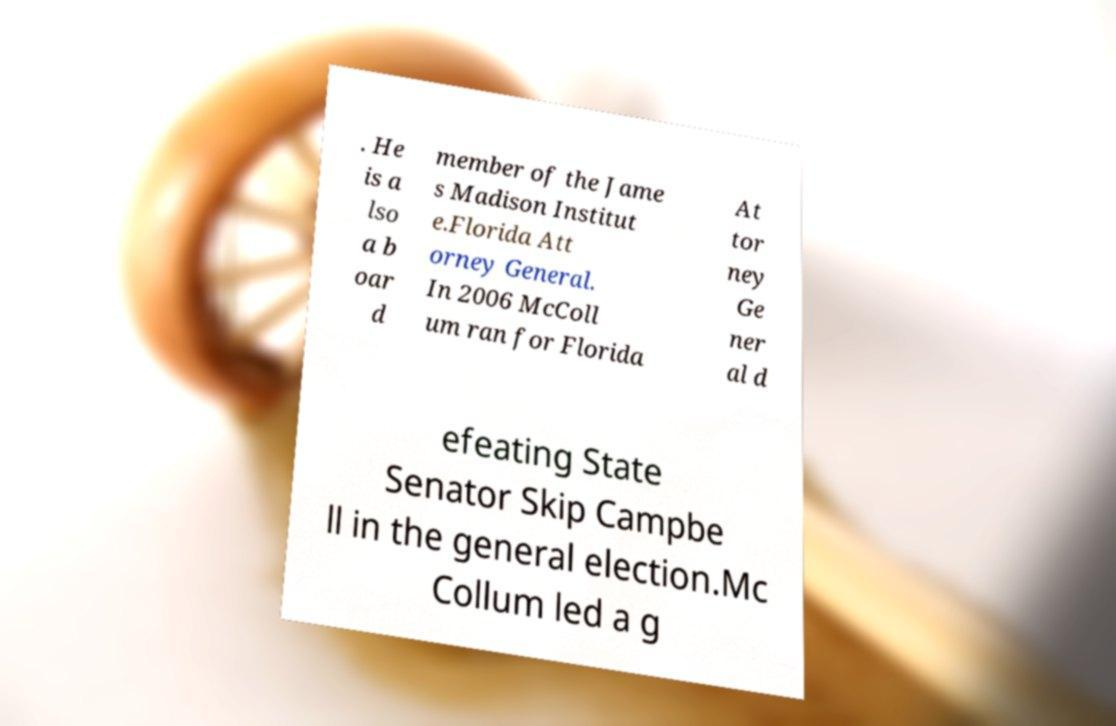Could you assist in decoding the text presented in this image and type it out clearly? . He is a lso a b oar d member of the Jame s Madison Institut e.Florida Att orney General. In 2006 McColl um ran for Florida At tor ney Ge ner al d efeating State Senator Skip Campbe ll in the general election.Mc Collum led a g 